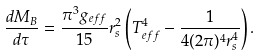<formula> <loc_0><loc_0><loc_500><loc_500>\frac { d M _ { B } } { d \tau } = \frac { \pi ^ { 3 } g _ { e f f } } { 1 5 } r _ { s } ^ { 2 } \left ( T _ { e f f } ^ { 4 } - \frac { 1 } { 4 ( 2 \pi ) ^ { 4 } r _ { s } ^ { 4 } } \right ) .</formula> 